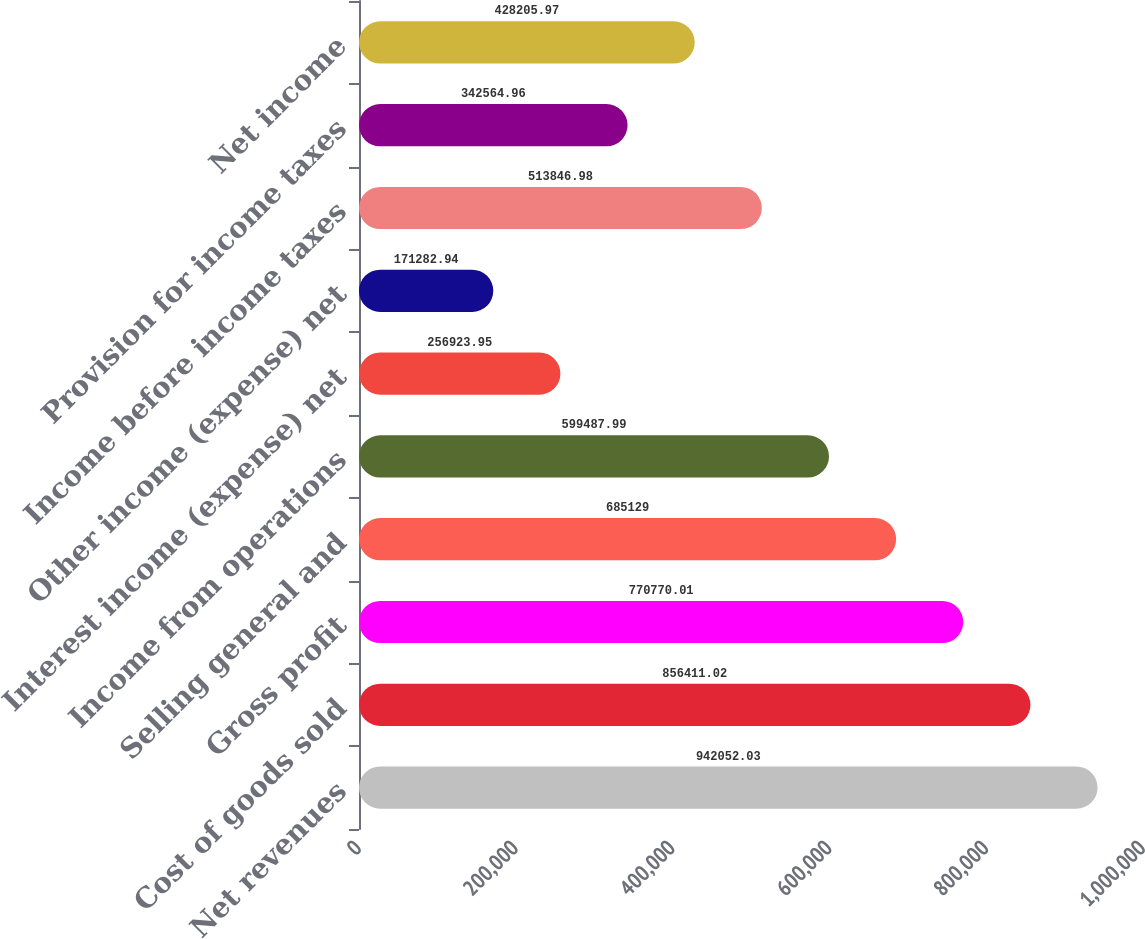Convert chart. <chart><loc_0><loc_0><loc_500><loc_500><bar_chart><fcel>Net revenues<fcel>Cost of goods sold<fcel>Gross profit<fcel>Selling general and<fcel>Income from operations<fcel>Interest income (expense) net<fcel>Other income (expense) net<fcel>Income before income taxes<fcel>Provision for income taxes<fcel>Net income<nl><fcel>942052<fcel>856411<fcel>770770<fcel>685129<fcel>599488<fcel>256924<fcel>171283<fcel>513847<fcel>342565<fcel>428206<nl></chart> 